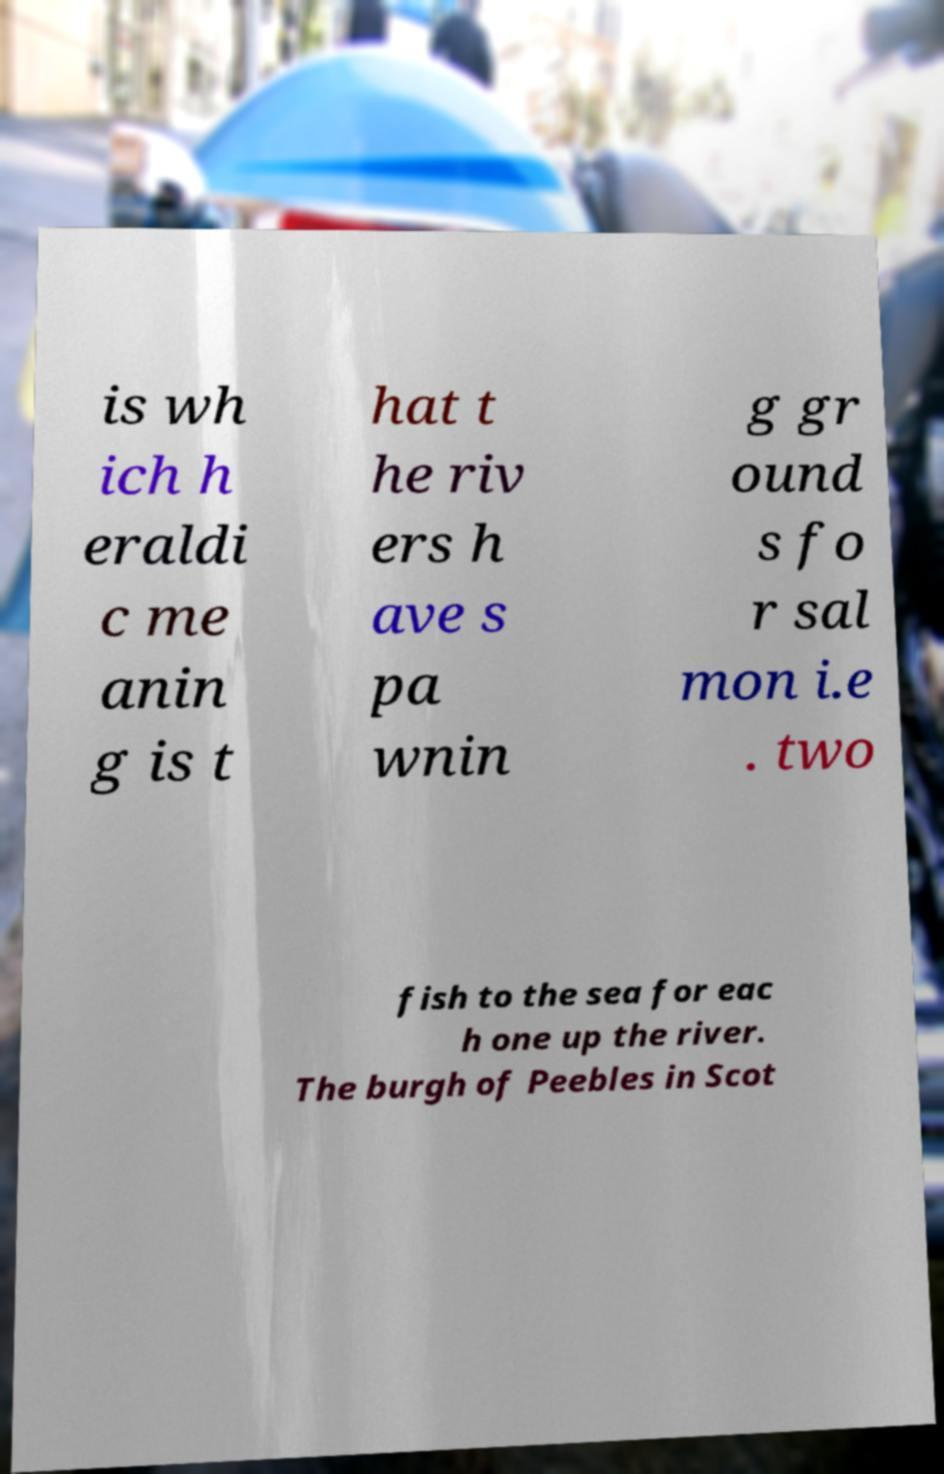Could you extract and type out the text from this image? is wh ich h eraldi c me anin g is t hat t he riv ers h ave s pa wnin g gr ound s fo r sal mon i.e . two fish to the sea for eac h one up the river. The burgh of Peebles in Scot 